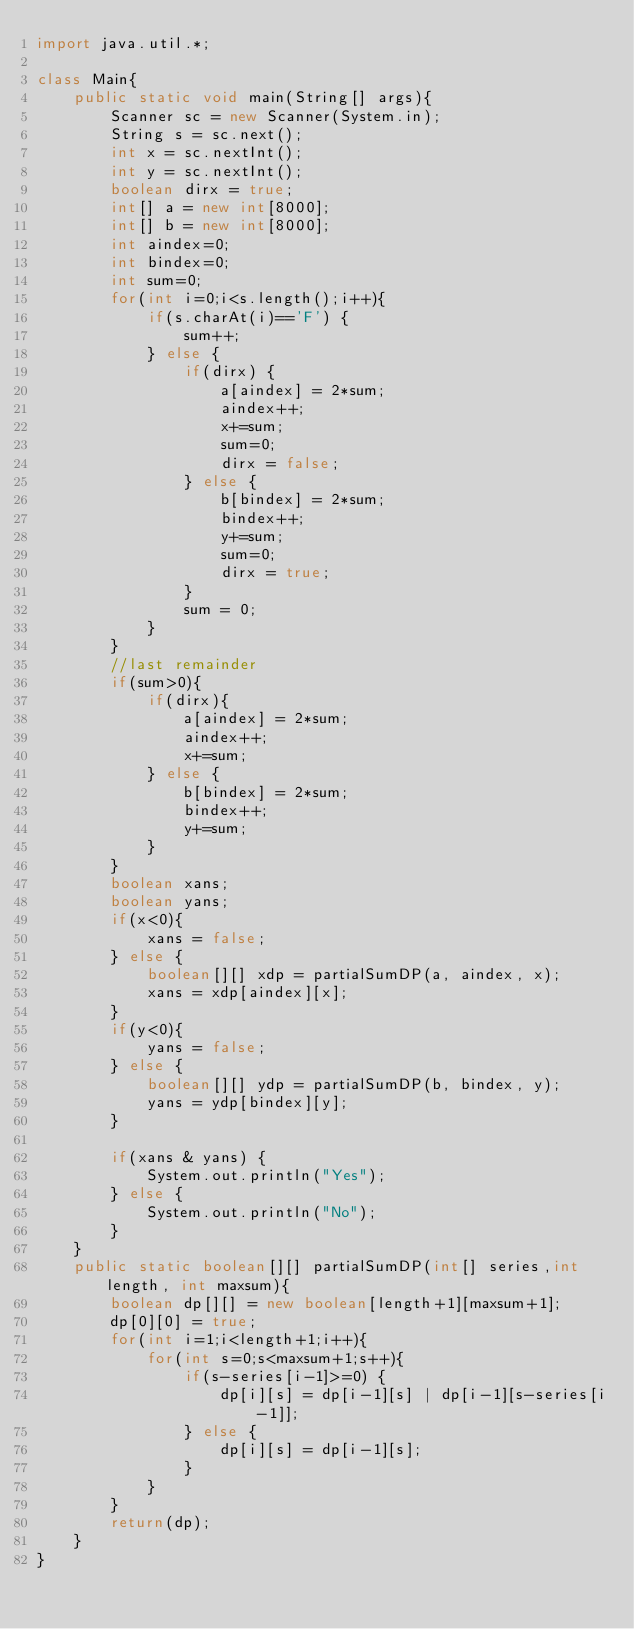<code> <loc_0><loc_0><loc_500><loc_500><_Java_>import java.util.*;

class Main{
    public static void main(String[] args){
        Scanner sc = new Scanner(System.in);
        String s = sc.next();
        int x = sc.nextInt();
        int y = sc.nextInt();
        boolean dirx = true;
        int[] a = new int[8000];
        int[] b = new int[8000];
        int aindex=0;
        int bindex=0;
        int sum=0;
        for(int i=0;i<s.length();i++){
            if(s.charAt(i)=='F') {
                sum++;
            } else {
                if(dirx) {
                    a[aindex] = 2*sum;
                    aindex++;
                    x+=sum;
                    sum=0;
                    dirx = false;
                } else {
                    b[bindex] = 2*sum;
                    bindex++;
                    y+=sum;
                    sum=0;
                    dirx = true;
                }
                sum = 0;
            }
        }
        //last remainder
        if(sum>0){
            if(dirx){
                a[aindex] = 2*sum;
                aindex++;
                x+=sum;
            } else {
                b[bindex] = 2*sum;
                bindex++;
                y+=sum;
            }
        }
        boolean xans;
        boolean yans;
        if(x<0){
            xans = false;
        } else {
            boolean[][] xdp = partialSumDP(a, aindex, x);
            xans = xdp[aindex][x];
        }
        if(y<0){
            yans = false;
        } else {
            boolean[][] ydp = partialSumDP(b, bindex, y);
            yans = ydp[bindex][y];
        }

        if(xans & yans) {
            System.out.println("Yes");
        } else {
            System.out.println("No");
        }
    }
    public static boolean[][] partialSumDP(int[] series,int length, int maxsum){
        boolean dp[][] = new boolean[length+1][maxsum+1];
        dp[0][0] = true;
        for(int i=1;i<length+1;i++){
            for(int s=0;s<maxsum+1;s++){
                if(s-series[i-1]>=0) {
                    dp[i][s] = dp[i-1][s] | dp[i-1][s-series[i-1]];
                } else {
                    dp[i][s] = dp[i-1][s];
                }
            }
        }
        return(dp);
    }
}</code> 